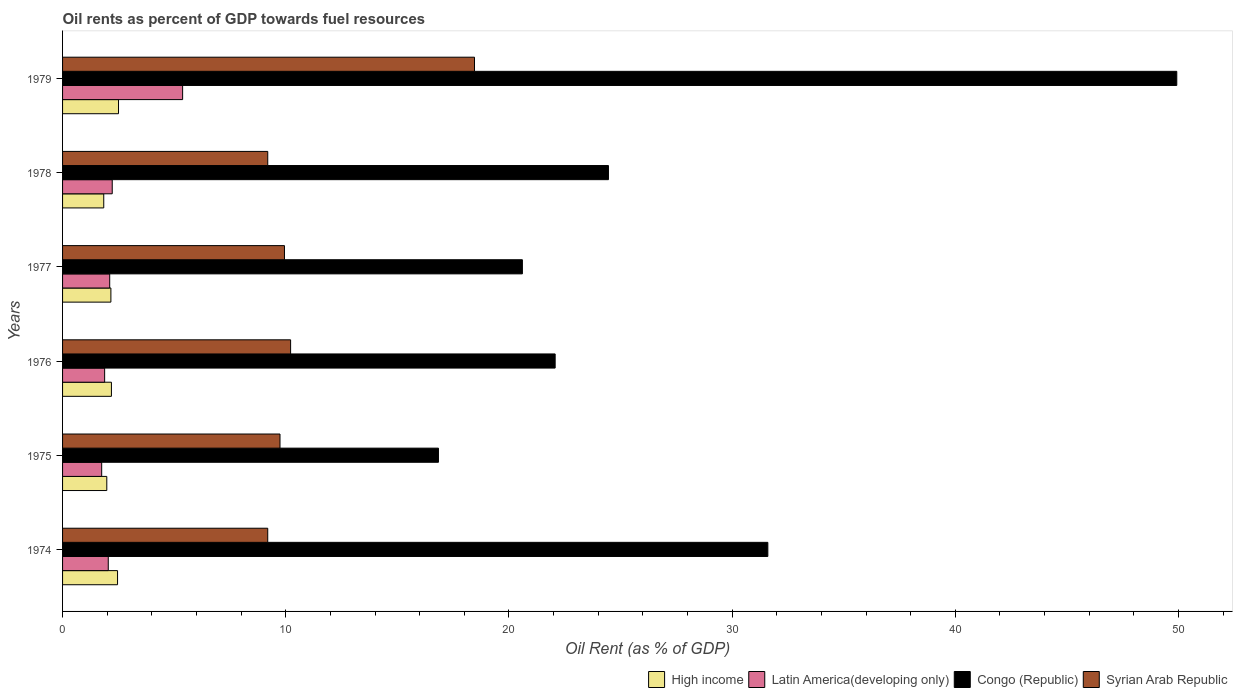How many different coloured bars are there?
Provide a short and direct response. 4. How many groups of bars are there?
Keep it short and to the point. 6. Are the number of bars per tick equal to the number of legend labels?
Offer a terse response. Yes. Are the number of bars on each tick of the Y-axis equal?
Keep it short and to the point. Yes. How many bars are there on the 3rd tick from the top?
Provide a short and direct response. 4. What is the label of the 6th group of bars from the top?
Give a very brief answer. 1974. In how many cases, is the number of bars for a given year not equal to the number of legend labels?
Your response must be concise. 0. What is the oil rent in Congo (Republic) in 1975?
Your answer should be very brief. 16.84. Across all years, what is the maximum oil rent in Congo (Republic)?
Provide a short and direct response. 49.92. Across all years, what is the minimum oil rent in Congo (Republic)?
Ensure brevity in your answer.  16.84. In which year was the oil rent in Syrian Arab Republic maximum?
Offer a very short reply. 1979. In which year was the oil rent in Syrian Arab Republic minimum?
Keep it short and to the point. 1974. What is the total oil rent in Latin America(developing only) in the graph?
Provide a succinct answer. 15.4. What is the difference between the oil rent in Syrian Arab Republic in 1974 and that in 1978?
Ensure brevity in your answer.  -0. What is the difference between the oil rent in Congo (Republic) in 1978 and the oil rent in High income in 1975?
Offer a terse response. 22.48. What is the average oil rent in Congo (Republic) per year?
Provide a succinct answer. 27.58. In the year 1976, what is the difference between the oil rent in Syrian Arab Republic and oil rent in High income?
Offer a terse response. 8.03. What is the ratio of the oil rent in Syrian Arab Republic in 1974 to that in 1976?
Offer a terse response. 0.9. Is the oil rent in Latin America(developing only) in 1977 less than that in 1979?
Offer a terse response. Yes. What is the difference between the highest and the second highest oil rent in Congo (Republic)?
Ensure brevity in your answer.  18.32. What is the difference between the highest and the lowest oil rent in Latin America(developing only)?
Your answer should be compact. 3.63. In how many years, is the oil rent in Congo (Republic) greater than the average oil rent in Congo (Republic) taken over all years?
Make the answer very short. 2. Is the sum of the oil rent in Latin America(developing only) in 1976 and 1978 greater than the maximum oil rent in Congo (Republic) across all years?
Your answer should be compact. No. What does the 1st bar from the top in 1976 represents?
Offer a very short reply. Syrian Arab Republic. What does the 4th bar from the bottom in 1975 represents?
Ensure brevity in your answer.  Syrian Arab Republic. Is it the case that in every year, the sum of the oil rent in Congo (Republic) and oil rent in Latin America(developing only) is greater than the oil rent in Syrian Arab Republic?
Provide a succinct answer. Yes. How many years are there in the graph?
Give a very brief answer. 6. What is the difference between two consecutive major ticks on the X-axis?
Give a very brief answer. 10. Does the graph contain grids?
Your response must be concise. No. What is the title of the graph?
Ensure brevity in your answer.  Oil rents as percent of GDP towards fuel resources. Does "Andorra" appear as one of the legend labels in the graph?
Your answer should be compact. No. What is the label or title of the X-axis?
Your answer should be very brief. Oil Rent (as % of GDP). What is the label or title of the Y-axis?
Ensure brevity in your answer.  Years. What is the Oil Rent (as % of GDP) in High income in 1974?
Provide a short and direct response. 2.46. What is the Oil Rent (as % of GDP) in Latin America(developing only) in 1974?
Your answer should be very brief. 2.05. What is the Oil Rent (as % of GDP) of Congo (Republic) in 1974?
Your answer should be compact. 31.6. What is the Oil Rent (as % of GDP) of Syrian Arab Republic in 1974?
Ensure brevity in your answer.  9.19. What is the Oil Rent (as % of GDP) in High income in 1975?
Offer a very short reply. 1.98. What is the Oil Rent (as % of GDP) in Latin America(developing only) in 1975?
Make the answer very short. 1.75. What is the Oil Rent (as % of GDP) in Congo (Republic) in 1975?
Your answer should be very brief. 16.84. What is the Oil Rent (as % of GDP) of Syrian Arab Republic in 1975?
Make the answer very short. 9.74. What is the Oil Rent (as % of GDP) of High income in 1976?
Provide a short and direct response. 2.19. What is the Oil Rent (as % of GDP) of Latin America(developing only) in 1976?
Provide a succinct answer. 1.89. What is the Oil Rent (as % of GDP) of Congo (Republic) in 1976?
Offer a very short reply. 22.07. What is the Oil Rent (as % of GDP) in Syrian Arab Republic in 1976?
Offer a terse response. 10.22. What is the Oil Rent (as % of GDP) of High income in 1977?
Your response must be concise. 2.17. What is the Oil Rent (as % of GDP) of Latin America(developing only) in 1977?
Ensure brevity in your answer.  2.11. What is the Oil Rent (as % of GDP) of Congo (Republic) in 1977?
Keep it short and to the point. 20.6. What is the Oil Rent (as % of GDP) of Syrian Arab Republic in 1977?
Your answer should be very brief. 9.94. What is the Oil Rent (as % of GDP) in High income in 1978?
Ensure brevity in your answer.  1.85. What is the Oil Rent (as % of GDP) in Latin America(developing only) in 1978?
Your answer should be very brief. 2.23. What is the Oil Rent (as % of GDP) of Congo (Republic) in 1978?
Provide a short and direct response. 24.46. What is the Oil Rent (as % of GDP) of Syrian Arab Republic in 1978?
Ensure brevity in your answer.  9.19. What is the Oil Rent (as % of GDP) of High income in 1979?
Provide a succinct answer. 2.51. What is the Oil Rent (as % of GDP) in Latin America(developing only) in 1979?
Your answer should be very brief. 5.38. What is the Oil Rent (as % of GDP) in Congo (Republic) in 1979?
Your answer should be very brief. 49.92. What is the Oil Rent (as % of GDP) of Syrian Arab Republic in 1979?
Provide a short and direct response. 18.46. Across all years, what is the maximum Oil Rent (as % of GDP) in High income?
Offer a terse response. 2.51. Across all years, what is the maximum Oil Rent (as % of GDP) of Latin America(developing only)?
Your answer should be compact. 5.38. Across all years, what is the maximum Oil Rent (as % of GDP) of Congo (Republic)?
Provide a short and direct response. 49.92. Across all years, what is the maximum Oil Rent (as % of GDP) in Syrian Arab Republic?
Provide a succinct answer. 18.46. Across all years, what is the minimum Oil Rent (as % of GDP) in High income?
Offer a very short reply. 1.85. Across all years, what is the minimum Oil Rent (as % of GDP) in Latin America(developing only)?
Your answer should be compact. 1.75. Across all years, what is the minimum Oil Rent (as % of GDP) in Congo (Republic)?
Make the answer very short. 16.84. Across all years, what is the minimum Oil Rent (as % of GDP) in Syrian Arab Republic?
Your response must be concise. 9.19. What is the total Oil Rent (as % of GDP) in High income in the graph?
Keep it short and to the point. 13.15. What is the total Oil Rent (as % of GDP) in Latin America(developing only) in the graph?
Provide a short and direct response. 15.4. What is the total Oil Rent (as % of GDP) of Congo (Republic) in the graph?
Offer a terse response. 165.5. What is the total Oil Rent (as % of GDP) in Syrian Arab Republic in the graph?
Make the answer very short. 66.75. What is the difference between the Oil Rent (as % of GDP) in High income in 1974 and that in 1975?
Your answer should be compact. 0.48. What is the difference between the Oil Rent (as % of GDP) in Latin America(developing only) in 1974 and that in 1975?
Offer a terse response. 0.29. What is the difference between the Oil Rent (as % of GDP) of Congo (Republic) in 1974 and that in 1975?
Offer a terse response. 14.76. What is the difference between the Oil Rent (as % of GDP) of Syrian Arab Republic in 1974 and that in 1975?
Your answer should be compact. -0.55. What is the difference between the Oil Rent (as % of GDP) in High income in 1974 and that in 1976?
Provide a short and direct response. 0.27. What is the difference between the Oil Rent (as % of GDP) in Latin America(developing only) in 1974 and that in 1976?
Your response must be concise. 0.16. What is the difference between the Oil Rent (as % of GDP) in Congo (Republic) in 1974 and that in 1976?
Provide a succinct answer. 9.53. What is the difference between the Oil Rent (as % of GDP) of Syrian Arab Republic in 1974 and that in 1976?
Give a very brief answer. -1.02. What is the difference between the Oil Rent (as % of GDP) of High income in 1974 and that in 1977?
Offer a terse response. 0.3. What is the difference between the Oil Rent (as % of GDP) of Latin America(developing only) in 1974 and that in 1977?
Your answer should be compact. -0.06. What is the difference between the Oil Rent (as % of GDP) in Congo (Republic) in 1974 and that in 1977?
Keep it short and to the point. 11. What is the difference between the Oil Rent (as % of GDP) in Syrian Arab Republic in 1974 and that in 1977?
Keep it short and to the point. -0.75. What is the difference between the Oil Rent (as % of GDP) of High income in 1974 and that in 1978?
Keep it short and to the point. 0.62. What is the difference between the Oil Rent (as % of GDP) in Latin America(developing only) in 1974 and that in 1978?
Your response must be concise. -0.18. What is the difference between the Oil Rent (as % of GDP) in Congo (Republic) in 1974 and that in 1978?
Provide a short and direct response. 7.14. What is the difference between the Oil Rent (as % of GDP) of Syrian Arab Republic in 1974 and that in 1978?
Offer a terse response. -0. What is the difference between the Oil Rent (as % of GDP) of High income in 1974 and that in 1979?
Your response must be concise. -0.04. What is the difference between the Oil Rent (as % of GDP) in Latin America(developing only) in 1974 and that in 1979?
Keep it short and to the point. -3.33. What is the difference between the Oil Rent (as % of GDP) in Congo (Republic) in 1974 and that in 1979?
Keep it short and to the point. -18.32. What is the difference between the Oil Rent (as % of GDP) of Syrian Arab Republic in 1974 and that in 1979?
Your response must be concise. -9.26. What is the difference between the Oil Rent (as % of GDP) of High income in 1975 and that in 1976?
Ensure brevity in your answer.  -0.21. What is the difference between the Oil Rent (as % of GDP) in Latin America(developing only) in 1975 and that in 1976?
Your answer should be very brief. -0.13. What is the difference between the Oil Rent (as % of GDP) of Congo (Republic) in 1975 and that in 1976?
Give a very brief answer. -5.23. What is the difference between the Oil Rent (as % of GDP) in Syrian Arab Republic in 1975 and that in 1976?
Provide a succinct answer. -0.47. What is the difference between the Oil Rent (as % of GDP) in High income in 1975 and that in 1977?
Give a very brief answer. -0.18. What is the difference between the Oil Rent (as % of GDP) in Latin America(developing only) in 1975 and that in 1977?
Give a very brief answer. -0.36. What is the difference between the Oil Rent (as % of GDP) in Congo (Republic) in 1975 and that in 1977?
Your response must be concise. -3.76. What is the difference between the Oil Rent (as % of GDP) of Syrian Arab Republic in 1975 and that in 1977?
Your answer should be compact. -0.2. What is the difference between the Oil Rent (as % of GDP) in High income in 1975 and that in 1978?
Ensure brevity in your answer.  0.14. What is the difference between the Oil Rent (as % of GDP) in Latin America(developing only) in 1975 and that in 1978?
Make the answer very short. -0.47. What is the difference between the Oil Rent (as % of GDP) of Congo (Republic) in 1975 and that in 1978?
Offer a very short reply. -7.62. What is the difference between the Oil Rent (as % of GDP) in Syrian Arab Republic in 1975 and that in 1978?
Your response must be concise. 0.55. What is the difference between the Oil Rent (as % of GDP) of High income in 1975 and that in 1979?
Provide a succinct answer. -0.53. What is the difference between the Oil Rent (as % of GDP) of Latin America(developing only) in 1975 and that in 1979?
Make the answer very short. -3.63. What is the difference between the Oil Rent (as % of GDP) in Congo (Republic) in 1975 and that in 1979?
Provide a short and direct response. -33.08. What is the difference between the Oil Rent (as % of GDP) of Syrian Arab Republic in 1975 and that in 1979?
Your answer should be very brief. -8.71. What is the difference between the Oil Rent (as % of GDP) in High income in 1976 and that in 1977?
Your answer should be very brief. 0.02. What is the difference between the Oil Rent (as % of GDP) of Latin America(developing only) in 1976 and that in 1977?
Your answer should be compact. -0.23. What is the difference between the Oil Rent (as % of GDP) in Congo (Republic) in 1976 and that in 1977?
Your answer should be compact. 1.47. What is the difference between the Oil Rent (as % of GDP) in Syrian Arab Republic in 1976 and that in 1977?
Offer a very short reply. 0.28. What is the difference between the Oil Rent (as % of GDP) of High income in 1976 and that in 1978?
Offer a very short reply. 0.34. What is the difference between the Oil Rent (as % of GDP) of Latin America(developing only) in 1976 and that in 1978?
Provide a succinct answer. -0.34. What is the difference between the Oil Rent (as % of GDP) in Congo (Republic) in 1976 and that in 1978?
Your response must be concise. -2.39. What is the difference between the Oil Rent (as % of GDP) in Syrian Arab Republic in 1976 and that in 1978?
Give a very brief answer. 1.02. What is the difference between the Oil Rent (as % of GDP) of High income in 1976 and that in 1979?
Your answer should be compact. -0.32. What is the difference between the Oil Rent (as % of GDP) of Latin America(developing only) in 1976 and that in 1979?
Provide a succinct answer. -3.49. What is the difference between the Oil Rent (as % of GDP) in Congo (Republic) in 1976 and that in 1979?
Ensure brevity in your answer.  -27.85. What is the difference between the Oil Rent (as % of GDP) of Syrian Arab Republic in 1976 and that in 1979?
Your answer should be very brief. -8.24. What is the difference between the Oil Rent (as % of GDP) in High income in 1977 and that in 1978?
Provide a succinct answer. 0.32. What is the difference between the Oil Rent (as % of GDP) of Latin America(developing only) in 1977 and that in 1978?
Provide a succinct answer. -0.11. What is the difference between the Oil Rent (as % of GDP) of Congo (Republic) in 1977 and that in 1978?
Offer a terse response. -3.86. What is the difference between the Oil Rent (as % of GDP) of Syrian Arab Republic in 1977 and that in 1978?
Keep it short and to the point. 0.75. What is the difference between the Oil Rent (as % of GDP) of High income in 1977 and that in 1979?
Provide a succinct answer. -0.34. What is the difference between the Oil Rent (as % of GDP) of Latin America(developing only) in 1977 and that in 1979?
Provide a short and direct response. -3.27. What is the difference between the Oil Rent (as % of GDP) of Congo (Republic) in 1977 and that in 1979?
Ensure brevity in your answer.  -29.32. What is the difference between the Oil Rent (as % of GDP) of Syrian Arab Republic in 1977 and that in 1979?
Give a very brief answer. -8.51. What is the difference between the Oil Rent (as % of GDP) in High income in 1978 and that in 1979?
Provide a succinct answer. -0.66. What is the difference between the Oil Rent (as % of GDP) of Latin America(developing only) in 1978 and that in 1979?
Provide a short and direct response. -3.15. What is the difference between the Oil Rent (as % of GDP) in Congo (Republic) in 1978 and that in 1979?
Provide a short and direct response. -25.46. What is the difference between the Oil Rent (as % of GDP) of Syrian Arab Republic in 1978 and that in 1979?
Provide a short and direct response. -9.26. What is the difference between the Oil Rent (as % of GDP) of High income in 1974 and the Oil Rent (as % of GDP) of Latin America(developing only) in 1975?
Keep it short and to the point. 0.71. What is the difference between the Oil Rent (as % of GDP) in High income in 1974 and the Oil Rent (as % of GDP) in Congo (Republic) in 1975?
Your answer should be very brief. -14.38. What is the difference between the Oil Rent (as % of GDP) of High income in 1974 and the Oil Rent (as % of GDP) of Syrian Arab Republic in 1975?
Your answer should be very brief. -7.28. What is the difference between the Oil Rent (as % of GDP) in Latin America(developing only) in 1974 and the Oil Rent (as % of GDP) in Congo (Republic) in 1975?
Keep it short and to the point. -14.79. What is the difference between the Oil Rent (as % of GDP) of Latin America(developing only) in 1974 and the Oil Rent (as % of GDP) of Syrian Arab Republic in 1975?
Offer a very short reply. -7.7. What is the difference between the Oil Rent (as % of GDP) in Congo (Republic) in 1974 and the Oil Rent (as % of GDP) in Syrian Arab Republic in 1975?
Give a very brief answer. 21.86. What is the difference between the Oil Rent (as % of GDP) in High income in 1974 and the Oil Rent (as % of GDP) in Latin America(developing only) in 1976?
Provide a short and direct response. 0.58. What is the difference between the Oil Rent (as % of GDP) of High income in 1974 and the Oil Rent (as % of GDP) of Congo (Republic) in 1976?
Your answer should be very brief. -19.61. What is the difference between the Oil Rent (as % of GDP) of High income in 1974 and the Oil Rent (as % of GDP) of Syrian Arab Republic in 1976?
Offer a very short reply. -7.75. What is the difference between the Oil Rent (as % of GDP) of Latin America(developing only) in 1974 and the Oil Rent (as % of GDP) of Congo (Republic) in 1976?
Your response must be concise. -20.02. What is the difference between the Oil Rent (as % of GDP) in Latin America(developing only) in 1974 and the Oil Rent (as % of GDP) in Syrian Arab Republic in 1976?
Make the answer very short. -8.17. What is the difference between the Oil Rent (as % of GDP) of Congo (Republic) in 1974 and the Oil Rent (as % of GDP) of Syrian Arab Republic in 1976?
Your response must be concise. 21.38. What is the difference between the Oil Rent (as % of GDP) of High income in 1974 and the Oil Rent (as % of GDP) of Latin America(developing only) in 1977?
Ensure brevity in your answer.  0.35. What is the difference between the Oil Rent (as % of GDP) of High income in 1974 and the Oil Rent (as % of GDP) of Congo (Republic) in 1977?
Your answer should be very brief. -18.14. What is the difference between the Oil Rent (as % of GDP) of High income in 1974 and the Oil Rent (as % of GDP) of Syrian Arab Republic in 1977?
Your response must be concise. -7.48. What is the difference between the Oil Rent (as % of GDP) of Latin America(developing only) in 1974 and the Oil Rent (as % of GDP) of Congo (Republic) in 1977?
Your response must be concise. -18.56. What is the difference between the Oil Rent (as % of GDP) of Latin America(developing only) in 1974 and the Oil Rent (as % of GDP) of Syrian Arab Republic in 1977?
Ensure brevity in your answer.  -7.89. What is the difference between the Oil Rent (as % of GDP) of Congo (Republic) in 1974 and the Oil Rent (as % of GDP) of Syrian Arab Republic in 1977?
Give a very brief answer. 21.66. What is the difference between the Oil Rent (as % of GDP) of High income in 1974 and the Oil Rent (as % of GDP) of Latin America(developing only) in 1978?
Ensure brevity in your answer.  0.24. What is the difference between the Oil Rent (as % of GDP) in High income in 1974 and the Oil Rent (as % of GDP) in Congo (Republic) in 1978?
Provide a succinct answer. -22. What is the difference between the Oil Rent (as % of GDP) of High income in 1974 and the Oil Rent (as % of GDP) of Syrian Arab Republic in 1978?
Provide a succinct answer. -6.73. What is the difference between the Oil Rent (as % of GDP) in Latin America(developing only) in 1974 and the Oil Rent (as % of GDP) in Congo (Republic) in 1978?
Ensure brevity in your answer.  -22.41. What is the difference between the Oil Rent (as % of GDP) in Latin America(developing only) in 1974 and the Oil Rent (as % of GDP) in Syrian Arab Republic in 1978?
Give a very brief answer. -7.15. What is the difference between the Oil Rent (as % of GDP) of Congo (Republic) in 1974 and the Oil Rent (as % of GDP) of Syrian Arab Republic in 1978?
Keep it short and to the point. 22.41. What is the difference between the Oil Rent (as % of GDP) of High income in 1974 and the Oil Rent (as % of GDP) of Latin America(developing only) in 1979?
Keep it short and to the point. -2.92. What is the difference between the Oil Rent (as % of GDP) in High income in 1974 and the Oil Rent (as % of GDP) in Congo (Republic) in 1979?
Your answer should be compact. -47.46. What is the difference between the Oil Rent (as % of GDP) in High income in 1974 and the Oil Rent (as % of GDP) in Syrian Arab Republic in 1979?
Ensure brevity in your answer.  -15.99. What is the difference between the Oil Rent (as % of GDP) in Latin America(developing only) in 1974 and the Oil Rent (as % of GDP) in Congo (Republic) in 1979?
Your answer should be compact. -47.88. What is the difference between the Oil Rent (as % of GDP) in Latin America(developing only) in 1974 and the Oil Rent (as % of GDP) in Syrian Arab Republic in 1979?
Offer a terse response. -16.41. What is the difference between the Oil Rent (as % of GDP) of Congo (Republic) in 1974 and the Oil Rent (as % of GDP) of Syrian Arab Republic in 1979?
Your answer should be compact. 13.14. What is the difference between the Oil Rent (as % of GDP) of High income in 1975 and the Oil Rent (as % of GDP) of Latin America(developing only) in 1976?
Make the answer very short. 0.1. What is the difference between the Oil Rent (as % of GDP) of High income in 1975 and the Oil Rent (as % of GDP) of Congo (Republic) in 1976?
Your answer should be compact. -20.09. What is the difference between the Oil Rent (as % of GDP) in High income in 1975 and the Oil Rent (as % of GDP) in Syrian Arab Republic in 1976?
Your answer should be very brief. -8.24. What is the difference between the Oil Rent (as % of GDP) of Latin America(developing only) in 1975 and the Oil Rent (as % of GDP) of Congo (Republic) in 1976?
Provide a short and direct response. -20.32. What is the difference between the Oil Rent (as % of GDP) of Latin America(developing only) in 1975 and the Oil Rent (as % of GDP) of Syrian Arab Republic in 1976?
Make the answer very short. -8.46. What is the difference between the Oil Rent (as % of GDP) in Congo (Republic) in 1975 and the Oil Rent (as % of GDP) in Syrian Arab Republic in 1976?
Ensure brevity in your answer.  6.62. What is the difference between the Oil Rent (as % of GDP) in High income in 1975 and the Oil Rent (as % of GDP) in Latin America(developing only) in 1977?
Your response must be concise. -0.13. What is the difference between the Oil Rent (as % of GDP) of High income in 1975 and the Oil Rent (as % of GDP) of Congo (Republic) in 1977?
Give a very brief answer. -18.62. What is the difference between the Oil Rent (as % of GDP) of High income in 1975 and the Oil Rent (as % of GDP) of Syrian Arab Republic in 1977?
Provide a short and direct response. -7.96. What is the difference between the Oil Rent (as % of GDP) in Latin America(developing only) in 1975 and the Oil Rent (as % of GDP) in Congo (Republic) in 1977?
Your answer should be compact. -18.85. What is the difference between the Oil Rent (as % of GDP) in Latin America(developing only) in 1975 and the Oil Rent (as % of GDP) in Syrian Arab Republic in 1977?
Your answer should be very brief. -8.19. What is the difference between the Oil Rent (as % of GDP) of Congo (Republic) in 1975 and the Oil Rent (as % of GDP) of Syrian Arab Republic in 1977?
Your answer should be very brief. 6.9. What is the difference between the Oil Rent (as % of GDP) of High income in 1975 and the Oil Rent (as % of GDP) of Latin America(developing only) in 1978?
Provide a succinct answer. -0.24. What is the difference between the Oil Rent (as % of GDP) in High income in 1975 and the Oil Rent (as % of GDP) in Congo (Republic) in 1978?
Your response must be concise. -22.48. What is the difference between the Oil Rent (as % of GDP) of High income in 1975 and the Oil Rent (as % of GDP) of Syrian Arab Republic in 1978?
Provide a short and direct response. -7.21. What is the difference between the Oil Rent (as % of GDP) of Latin America(developing only) in 1975 and the Oil Rent (as % of GDP) of Congo (Republic) in 1978?
Offer a very short reply. -22.71. What is the difference between the Oil Rent (as % of GDP) in Latin America(developing only) in 1975 and the Oil Rent (as % of GDP) in Syrian Arab Republic in 1978?
Your answer should be compact. -7.44. What is the difference between the Oil Rent (as % of GDP) of Congo (Republic) in 1975 and the Oil Rent (as % of GDP) of Syrian Arab Republic in 1978?
Provide a succinct answer. 7.65. What is the difference between the Oil Rent (as % of GDP) of High income in 1975 and the Oil Rent (as % of GDP) of Latin America(developing only) in 1979?
Offer a terse response. -3.4. What is the difference between the Oil Rent (as % of GDP) of High income in 1975 and the Oil Rent (as % of GDP) of Congo (Republic) in 1979?
Provide a succinct answer. -47.94. What is the difference between the Oil Rent (as % of GDP) of High income in 1975 and the Oil Rent (as % of GDP) of Syrian Arab Republic in 1979?
Keep it short and to the point. -16.48. What is the difference between the Oil Rent (as % of GDP) of Latin America(developing only) in 1975 and the Oil Rent (as % of GDP) of Congo (Republic) in 1979?
Provide a succinct answer. -48.17. What is the difference between the Oil Rent (as % of GDP) in Latin America(developing only) in 1975 and the Oil Rent (as % of GDP) in Syrian Arab Republic in 1979?
Your answer should be compact. -16.7. What is the difference between the Oil Rent (as % of GDP) of Congo (Republic) in 1975 and the Oil Rent (as % of GDP) of Syrian Arab Republic in 1979?
Your answer should be very brief. -1.62. What is the difference between the Oil Rent (as % of GDP) in High income in 1976 and the Oil Rent (as % of GDP) in Latin America(developing only) in 1977?
Give a very brief answer. 0.08. What is the difference between the Oil Rent (as % of GDP) of High income in 1976 and the Oil Rent (as % of GDP) of Congo (Republic) in 1977?
Offer a terse response. -18.41. What is the difference between the Oil Rent (as % of GDP) in High income in 1976 and the Oil Rent (as % of GDP) in Syrian Arab Republic in 1977?
Offer a very short reply. -7.75. What is the difference between the Oil Rent (as % of GDP) in Latin America(developing only) in 1976 and the Oil Rent (as % of GDP) in Congo (Republic) in 1977?
Your answer should be compact. -18.72. What is the difference between the Oil Rent (as % of GDP) in Latin America(developing only) in 1976 and the Oil Rent (as % of GDP) in Syrian Arab Republic in 1977?
Your answer should be very brief. -8.06. What is the difference between the Oil Rent (as % of GDP) of Congo (Republic) in 1976 and the Oil Rent (as % of GDP) of Syrian Arab Republic in 1977?
Offer a terse response. 12.13. What is the difference between the Oil Rent (as % of GDP) in High income in 1976 and the Oil Rent (as % of GDP) in Latin America(developing only) in 1978?
Keep it short and to the point. -0.04. What is the difference between the Oil Rent (as % of GDP) of High income in 1976 and the Oil Rent (as % of GDP) of Congo (Republic) in 1978?
Your answer should be compact. -22.27. What is the difference between the Oil Rent (as % of GDP) of High income in 1976 and the Oil Rent (as % of GDP) of Syrian Arab Republic in 1978?
Offer a terse response. -7. What is the difference between the Oil Rent (as % of GDP) in Latin America(developing only) in 1976 and the Oil Rent (as % of GDP) in Congo (Republic) in 1978?
Your answer should be very brief. -22.57. What is the difference between the Oil Rent (as % of GDP) of Latin America(developing only) in 1976 and the Oil Rent (as % of GDP) of Syrian Arab Republic in 1978?
Give a very brief answer. -7.31. What is the difference between the Oil Rent (as % of GDP) in Congo (Republic) in 1976 and the Oil Rent (as % of GDP) in Syrian Arab Republic in 1978?
Offer a terse response. 12.88. What is the difference between the Oil Rent (as % of GDP) in High income in 1976 and the Oil Rent (as % of GDP) in Latin America(developing only) in 1979?
Your answer should be very brief. -3.19. What is the difference between the Oil Rent (as % of GDP) in High income in 1976 and the Oil Rent (as % of GDP) in Congo (Republic) in 1979?
Provide a short and direct response. -47.73. What is the difference between the Oil Rent (as % of GDP) in High income in 1976 and the Oil Rent (as % of GDP) in Syrian Arab Republic in 1979?
Offer a very short reply. -16.27. What is the difference between the Oil Rent (as % of GDP) of Latin America(developing only) in 1976 and the Oil Rent (as % of GDP) of Congo (Republic) in 1979?
Ensure brevity in your answer.  -48.04. What is the difference between the Oil Rent (as % of GDP) in Latin America(developing only) in 1976 and the Oil Rent (as % of GDP) in Syrian Arab Republic in 1979?
Offer a very short reply. -16.57. What is the difference between the Oil Rent (as % of GDP) in Congo (Republic) in 1976 and the Oil Rent (as % of GDP) in Syrian Arab Republic in 1979?
Give a very brief answer. 3.61. What is the difference between the Oil Rent (as % of GDP) in High income in 1977 and the Oil Rent (as % of GDP) in Latin America(developing only) in 1978?
Give a very brief answer. -0.06. What is the difference between the Oil Rent (as % of GDP) of High income in 1977 and the Oil Rent (as % of GDP) of Congo (Republic) in 1978?
Keep it short and to the point. -22.29. What is the difference between the Oil Rent (as % of GDP) of High income in 1977 and the Oil Rent (as % of GDP) of Syrian Arab Republic in 1978?
Your answer should be very brief. -7.03. What is the difference between the Oil Rent (as % of GDP) of Latin America(developing only) in 1977 and the Oil Rent (as % of GDP) of Congo (Republic) in 1978?
Offer a terse response. -22.35. What is the difference between the Oil Rent (as % of GDP) in Latin America(developing only) in 1977 and the Oil Rent (as % of GDP) in Syrian Arab Republic in 1978?
Your response must be concise. -7.08. What is the difference between the Oil Rent (as % of GDP) of Congo (Republic) in 1977 and the Oil Rent (as % of GDP) of Syrian Arab Republic in 1978?
Offer a very short reply. 11.41. What is the difference between the Oil Rent (as % of GDP) of High income in 1977 and the Oil Rent (as % of GDP) of Latin America(developing only) in 1979?
Your response must be concise. -3.21. What is the difference between the Oil Rent (as % of GDP) in High income in 1977 and the Oil Rent (as % of GDP) in Congo (Republic) in 1979?
Ensure brevity in your answer.  -47.76. What is the difference between the Oil Rent (as % of GDP) in High income in 1977 and the Oil Rent (as % of GDP) in Syrian Arab Republic in 1979?
Provide a succinct answer. -16.29. What is the difference between the Oil Rent (as % of GDP) in Latin America(developing only) in 1977 and the Oil Rent (as % of GDP) in Congo (Republic) in 1979?
Your answer should be compact. -47.81. What is the difference between the Oil Rent (as % of GDP) in Latin America(developing only) in 1977 and the Oil Rent (as % of GDP) in Syrian Arab Republic in 1979?
Ensure brevity in your answer.  -16.34. What is the difference between the Oil Rent (as % of GDP) of Congo (Republic) in 1977 and the Oil Rent (as % of GDP) of Syrian Arab Republic in 1979?
Ensure brevity in your answer.  2.15. What is the difference between the Oil Rent (as % of GDP) of High income in 1978 and the Oil Rent (as % of GDP) of Latin America(developing only) in 1979?
Offer a very short reply. -3.53. What is the difference between the Oil Rent (as % of GDP) in High income in 1978 and the Oil Rent (as % of GDP) in Congo (Republic) in 1979?
Your response must be concise. -48.08. What is the difference between the Oil Rent (as % of GDP) in High income in 1978 and the Oil Rent (as % of GDP) in Syrian Arab Republic in 1979?
Make the answer very short. -16.61. What is the difference between the Oil Rent (as % of GDP) in Latin America(developing only) in 1978 and the Oil Rent (as % of GDP) in Congo (Republic) in 1979?
Keep it short and to the point. -47.7. What is the difference between the Oil Rent (as % of GDP) of Latin America(developing only) in 1978 and the Oil Rent (as % of GDP) of Syrian Arab Republic in 1979?
Offer a very short reply. -16.23. What is the difference between the Oil Rent (as % of GDP) of Congo (Republic) in 1978 and the Oil Rent (as % of GDP) of Syrian Arab Republic in 1979?
Keep it short and to the point. 6. What is the average Oil Rent (as % of GDP) of High income per year?
Your answer should be very brief. 2.19. What is the average Oil Rent (as % of GDP) in Latin America(developing only) per year?
Give a very brief answer. 2.57. What is the average Oil Rent (as % of GDP) in Congo (Republic) per year?
Keep it short and to the point. 27.58. What is the average Oil Rent (as % of GDP) in Syrian Arab Republic per year?
Make the answer very short. 11.12. In the year 1974, what is the difference between the Oil Rent (as % of GDP) in High income and Oil Rent (as % of GDP) in Latin America(developing only)?
Offer a very short reply. 0.42. In the year 1974, what is the difference between the Oil Rent (as % of GDP) of High income and Oil Rent (as % of GDP) of Congo (Republic)?
Offer a terse response. -29.14. In the year 1974, what is the difference between the Oil Rent (as % of GDP) of High income and Oil Rent (as % of GDP) of Syrian Arab Republic?
Offer a very short reply. -6.73. In the year 1974, what is the difference between the Oil Rent (as % of GDP) of Latin America(developing only) and Oil Rent (as % of GDP) of Congo (Republic)?
Your answer should be compact. -29.55. In the year 1974, what is the difference between the Oil Rent (as % of GDP) of Latin America(developing only) and Oil Rent (as % of GDP) of Syrian Arab Republic?
Offer a very short reply. -7.15. In the year 1974, what is the difference between the Oil Rent (as % of GDP) of Congo (Republic) and Oil Rent (as % of GDP) of Syrian Arab Republic?
Keep it short and to the point. 22.41. In the year 1975, what is the difference between the Oil Rent (as % of GDP) of High income and Oil Rent (as % of GDP) of Latin America(developing only)?
Provide a short and direct response. 0.23. In the year 1975, what is the difference between the Oil Rent (as % of GDP) in High income and Oil Rent (as % of GDP) in Congo (Republic)?
Your answer should be very brief. -14.86. In the year 1975, what is the difference between the Oil Rent (as % of GDP) in High income and Oil Rent (as % of GDP) in Syrian Arab Republic?
Provide a short and direct response. -7.76. In the year 1975, what is the difference between the Oil Rent (as % of GDP) in Latin America(developing only) and Oil Rent (as % of GDP) in Congo (Republic)?
Give a very brief answer. -15.09. In the year 1975, what is the difference between the Oil Rent (as % of GDP) of Latin America(developing only) and Oil Rent (as % of GDP) of Syrian Arab Republic?
Provide a succinct answer. -7.99. In the year 1975, what is the difference between the Oil Rent (as % of GDP) in Congo (Republic) and Oil Rent (as % of GDP) in Syrian Arab Republic?
Provide a succinct answer. 7.1. In the year 1976, what is the difference between the Oil Rent (as % of GDP) in High income and Oil Rent (as % of GDP) in Latin America(developing only)?
Your response must be concise. 0.3. In the year 1976, what is the difference between the Oil Rent (as % of GDP) in High income and Oil Rent (as % of GDP) in Congo (Republic)?
Keep it short and to the point. -19.88. In the year 1976, what is the difference between the Oil Rent (as % of GDP) of High income and Oil Rent (as % of GDP) of Syrian Arab Republic?
Your response must be concise. -8.03. In the year 1976, what is the difference between the Oil Rent (as % of GDP) in Latin America(developing only) and Oil Rent (as % of GDP) in Congo (Republic)?
Your answer should be very brief. -20.19. In the year 1976, what is the difference between the Oil Rent (as % of GDP) in Latin America(developing only) and Oil Rent (as % of GDP) in Syrian Arab Republic?
Keep it short and to the point. -8.33. In the year 1976, what is the difference between the Oil Rent (as % of GDP) in Congo (Republic) and Oil Rent (as % of GDP) in Syrian Arab Republic?
Give a very brief answer. 11.85. In the year 1977, what is the difference between the Oil Rent (as % of GDP) in High income and Oil Rent (as % of GDP) in Latin America(developing only)?
Ensure brevity in your answer.  0.05. In the year 1977, what is the difference between the Oil Rent (as % of GDP) of High income and Oil Rent (as % of GDP) of Congo (Republic)?
Your answer should be very brief. -18.44. In the year 1977, what is the difference between the Oil Rent (as % of GDP) of High income and Oil Rent (as % of GDP) of Syrian Arab Republic?
Your answer should be compact. -7.78. In the year 1977, what is the difference between the Oil Rent (as % of GDP) of Latin America(developing only) and Oil Rent (as % of GDP) of Congo (Republic)?
Give a very brief answer. -18.49. In the year 1977, what is the difference between the Oil Rent (as % of GDP) in Latin America(developing only) and Oil Rent (as % of GDP) in Syrian Arab Republic?
Ensure brevity in your answer.  -7.83. In the year 1977, what is the difference between the Oil Rent (as % of GDP) of Congo (Republic) and Oil Rent (as % of GDP) of Syrian Arab Republic?
Your response must be concise. 10.66. In the year 1978, what is the difference between the Oil Rent (as % of GDP) in High income and Oil Rent (as % of GDP) in Latin America(developing only)?
Your response must be concise. -0.38. In the year 1978, what is the difference between the Oil Rent (as % of GDP) in High income and Oil Rent (as % of GDP) in Congo (Republic)?
Give a very brief answer. -22.61. In the year 1978, what is the difference between the Oil Rent (as % of GDP) of High income and Oil Rent (as % of GDP) of Syrian Arab Republic?
Ensure brevity in your answer.  -7.35. In the year 1978, what is the difference between the Oil Rent (as % of GDP) in Latin America(developing only) and Oil Rent (as % of GDP) in Congo (Republic)?
Keep it short and to the point. -22.23. In the year 1978, what is the difference between the Oil Rent (as % of GDP) of Latin America(developing only) and Oil Rent (as % of GDP) of Syrian Arab Republic?
Offer a very short reply. -6.97. In the year 1978, what is the difference between the Oil Rent (as % of GDP) of Congo (Republic) and Oil Rent (as % of GDP) of Syrian Arab Republic?
Your answer should be very brief. 15.27. In the year 1979, what is the difference between the Oil Rent (as % of GDP) in High income and Oil Rent (as % of GDP) in Latin America(developing only)?
Your answer should be very brief. -2.87. In the year 1979, what is the difference between the Oil Rent (as % of GDP) in High income and Oil Rent (as % of GDP) in Congo (Republic)?
Keep it short and to the point. -47.42. In the year 1979, what is the difference between the Oil Rent (as % of GDP) of High income and Oil Rent (as % of GDP) of Syrian Arab Republic?
Offer a very short reply. -15.95. In the year 1979, what is the difference between the Oil Rent (as % of GDP) in Latin America(developing only) and Oil Rent (as % of GDP) in Congo (Republic)?
Make the answer very short. -44.54. In the year 1979, what is the difference between the Oil Rent (as % of GDP) in Latin America(developing only) and Oil Rent (as % of GDP) in Syrian Arab Republic?
Offer a very short reply. -13.08. In the year 1979, what is the difference between the Oil Rent (as % of GDP) in Congo (Republic) and Oil Rent (as % of GDP) in Syrian Arab Republic?
Offer a very short reply. 31.47. What is the ratio of the Oil Rent (as % of GDP) in High income in 1974 to that in 1975?
Make the answer very short. 1.24. What is the ratio of the Oil Rent (as % of GDP) of Latin America(developing only) in 1974 to that in 1975?
Ensure brevity in your answer.  1.17. What is the ratio of the Oil Rent (as % of GDP) in Congo (Republic) in 1974 to that in 1975?
Ensure brevity in your answer.  1.88. What is the ratio of the Oil Rent (as % of GDP) in Syrian Arab Republic in 1974 to that in 1975?
Ensure brevity in your answer.  0.94. What is the ratio of the Oil Rent (as % of GDP) in High income in 1974 to that in 1976?
Offer a terse response. 1.13. What is the ratio of the Oil Rent (as % of GDP) in Latin America(developing only) in 1974 to that in 1976?
Offer a terse response. 1.09. What is the ratio of the Oil Rent (as % of GDP) in Congo (Republic) in 1974 to that in 1976?
Offer a terse response. 1.43. What is the ratio of the Oil Rent (as % of GDP) in Syrian Arab Republic in 1974 to that in 1976?
Your answer should be very brief. 0.9. What is the ratio of the Oil Rent (as % of GDP) in High income in 1974 to that in 1977?
Your response must be concise. 1.14. What is the ratio of the Oil Rent (as % of GDP) of Latin America(developing only) in 1974 to that in 1977?
Provide a succinct answer. 0.97. What is the ratio of the Oil Rent (as % of GDP) in Congo (Republic) in 1974 to that in 1977?
Make the answer very short. 1.53. What is the ratio of the Oil Rent (as % of GDP) of Syrian Arab Republic in 1974 to that in 1977?
Your answer should be very brief. 0.92. What is the ratio of the Oil Rent (as % of GDP) in High income in 1974 to that in 1978?
Ensure brevity in your answer.  1.34. What is the ratio of the Oil Rent (as % of GDP) in Latin America(developing only) in 1974 to that in 1978?
Your answer should be compact. 0.92. What is the ratio of the Oil Rent (as % of GDP) in Congo (Republic) in 1974 to that in 1978?
Your answer should be very brief. 1.29. What is the ratio of the Oil Rent (as % of GDP) in Syrian Arab Republic in 1974 to that in 1978?
Offer a terse response. 1. What is the ratio of the Oil Rent (as % of GDP) of High income in 1974 to that in 1979?
Ensure brevity in your answer.  0.98. What is the ratio of the Oil Rent (as % of GDP) in Latin America(developing only) in 1974 to that in 1979?
Keep it short and to the point. 0.38. What is the ratio of the Oil Rent (as % of GDP) in Congo (Republic) in 1974 to that in 1979?
Your answer should be very brief. 0.63. What is the ratio of the Oil Rent (as % of GDP) in Syrian Arab Republic in 1974 to that in 1979?
Offer a very short reply. 0.5. What is the ratio of the Oil Rent (as % of GDP) in High income in 1975 to that in 1976?
Your answer should be very brief. 0.91. What is the ratio of the Oil Rent (as % of GDP) in Congo (Republic) in 1975 to that in 1976?
Make the answer very short. 0.76. What is the ratio of the Oil Rent (as % of GDP) of Syrian Arab Republic in 1975 to that in 1976?
Your answer should be compact. 0.95. What is the ratio of the Oil Rent (as % of GDP) of High income in 1975 to that in 1977?
Give a very brief answer. 0.92. What is the ratio of the Oil Rent (as % of GDP) in Latin America(developing only) in 1975 to that in 1977?
Make the answer very short. 0.83. What is the ratio of the Oil Rent (as % of GDP) of Congo (Republic) in 1975 to that in 1977?
Your response must be concise. 0.82. What is the ratio of the Oil Rent (as % of GDP) in Syrian Arab Republic in 1975 to that in 1977?
Make the answer very short. 0.98. What is the ratio of the Oil Rent (as % of GDP) of High income in 1975 to that in 1978?
Offer a very short reply. 1.07. What is the ratio of the Oil Rent (as % of GDP) of Latin America(developing only) in 1975 to that in 1978?
Offer a very short reply. 0.79. What is the ratio of the Oil Rent (as % of GDP) of Congo (Republic) in 1975 to that in 1978?
Your answer should be compact. 0.69. What is the ratio of the Oil Rent (as % of GDP) of Syrian Arab Republic in 1975 to that in 1978?
Give a very brief answer. 1.06. What is the ratio of the Oil Rent (as % of GDP) in High income in 1975 to that in 1979?
Make the answer very short. 0.79. What is the ratio of the Oil Rent (as % of GDP) in Latin America(developing only) in 1975 to that in 1979?
Offer a very short reply. 0.33. What is the ratio of the Oil Rent (as % of GDP) in Congo (Republic) in 1975 to that in 1979?
Ensure brevity in your answer.  0.34. What is the ratio of the Oil Rent (as % of GDP) in Syrian Arab Republic in 1975 to that in 1979?
Ensure brevity in your answer.  0.53. What is the ratio of the Oil Rent (as % of GDP) in High income in 1976 to that in 1977?
Keep it short and to the point. 1.01. What is the ratio of the Oil Rent (as % of GDP) in Latin America(developing only) in 1976 to that in 1977?
Give a very brief answer. 0.89. What is the ratio of the Oil Rent (as % of GDP) of Congo (Republic) in 1976 to that in 1977?
Offer a very short reply. 1.07. What is the ratio of the Oil Rent (as % of GDP) in Syrian Arab Republic in 1976 to that in 1977?
Your answer should be very brief. 1.03. What is the ratio of the Oil Rent (as % of GDP) of High income in 1976 to that in 1978?
Your answer should be compact. 1.19. What is the ratio of the Oil Rent (as % of GDP) in Latin America(developing only) in 1976 to that in 1978?
Provide a succinct answer. 0.85. What is the ratio of the Oil Rent (as % of GDP) in Congo (Republic) in 1976 to that in 1978?
Offer a terse response. 0.9. What is the ratio of the Oil Rent (as % of GDP) of Syrian Arab Republic in 1976 to that in 1978?
Make the answer very short. 1.11. What is the ratio of the Oil Rent (as % of GDP) in High income in 1976 to that in 1979?
Your response must be concise. 0.87. What is the ratio of the Oil Rent (as % of GDP) of Latin America(developing only) in 1976 to that in 1979?
Provide a short and direct response. 0.35. What is the ratio of the Oil Rent (as % of GDP) in Congo (Republic) in 1976 to that in 1979?
Give a very brief answer. 0.44. What is the ratio of the Oil Rent (as % of GDP) in Syrian Arab Republic in 1976 to that in 1979?
Provide a succinct answer. 0.55. What is the ratio of the Oil Rent (as % of GDP) in High income in 1977 to that in 1978?
Keep it short and to the point. 1.17. What is the ratio of the Oil Rent (as % of GDP) in Latin America(developing only) in 1977 to that in 1978?
Your answer should be compact. 0.95. What is the ratio of the Oil Rent (as % of GDP) in Congo (Republic) in 1977 to that in 1978?
Offer a terse response. 0.84. What is the ratio of the Oil Rent (as % of GDP) of Syrian Arab Republic in 1977 to that in 1978?
Offer a very short reply. 1.08. What is the ratio of the Oil Rent (as % of GDP) in High income in 1977 to that in 1979?
Your answer should be compact. 0.86. What is the ratio of the Oil Rent (as % of GDP) of Latin America(developing only) in 1977 to that in 1979?
Make the answer very short. 0.39. What is the ratio of the Oil Rent (as % of GDP) of Congo (Republic) in 1977 to that in 1979?
Ensure brevity in your answer.  0.41. What is the ratio of the Oil Rent (as % of GDP) of Syrian Arab Republic in 1977 to that in 1979?
Offer a terse response. 0.54. What is the ratio of the Oil Rent (as % of GDP) in High income in 1978 to that in 1979?
Make the answer very short. 0.74. What is the ratio of the Oil Rent (as % of GDP) of Latin America(developing only) in 1978 to that in 1979?
Your response must be concise. 0.41. What is the ratio of the Oil Rent (as % of GDP) in Congo (Republic) in 1978 to that in 1979?
Provide a short and direct response. 0.49. What is the ratio of the Oil Rent (as % of GDP) in Syrian Arab Republic in 1978 to that in 1979?
Your answer should be compact. 0.5. What is the difference between the highest and the second highest Oil Rent (as % of GDP) in High income?
Ensure brevity in your answer.  0.04. What is the difference between the highest and the second highest Oil Rent (as % of GDP) of Latin America(developing only)?
Make the answer very short. 3.15. What is the difference between the highest and the second highest Oil Rent (as % of GDP) in Congo (Republic)?
Ensure brevity in your answer.  18.32. What is the difference between the highest and the second highest Oil Rent (as % of GDP) of Syrian Arab Republic?
Provide a succinct answer. 8.24. What is the difference between the highest and the lowest Oil Rent (as % of GDP) in High income?
Make the answer very short. 0.66. What is the difference between the highest and the lowest Oil Rent (as % of GDP) of Latin America(developing only)?
Give a very brief answer. 3.63. What is the difference between the highest and the lowest Oil Rent (as % of GDP) of Congo (Republic)?
Your answer should be very brief. 33.08. What is the difference between the highest and the lowest Oil Rent (as % of GDP) of Syrian Arab Republic?
Provide a succinct answer. 9.26. 